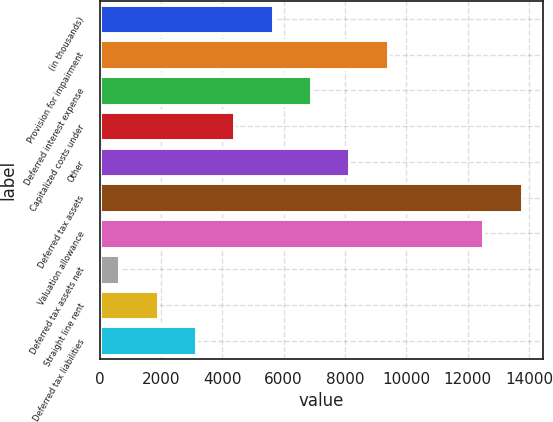Convert chart. <chart><loc_0><loc_0><loc_500><loc_500><bar_chart><fcel>(in thousands)<fcel>Provision for impairment<fcel>Deferred interest expense<fcel>Capitalized costs under<fcel>Other<fcel>Deferred tax assets<fcel>Valuation allowance<fcel>Deferred tax assets net<fcel>Straight line rent<fcel>Deferred tax liabilities<nl><fcel>5645.8<fcel>9397.9<fcel>6896.5<fcel>4395.1<fcel>8147.2<fcel>13757.7<fcel>12507<fcel>643<fcel>1893.7<fcel>3144.4<nl></chart> 